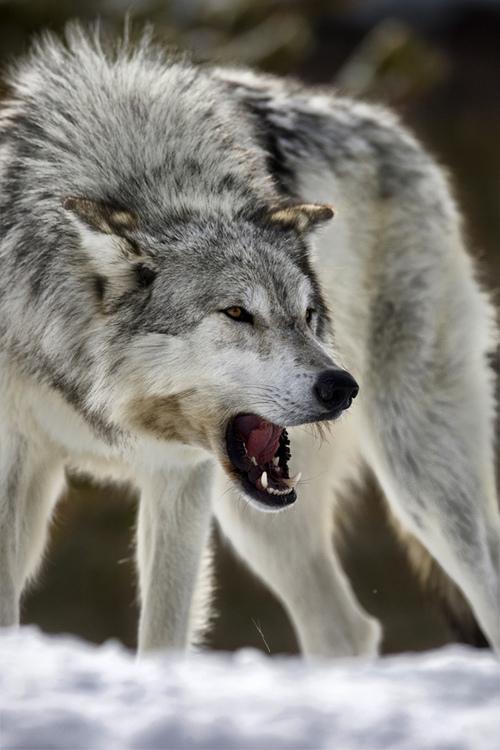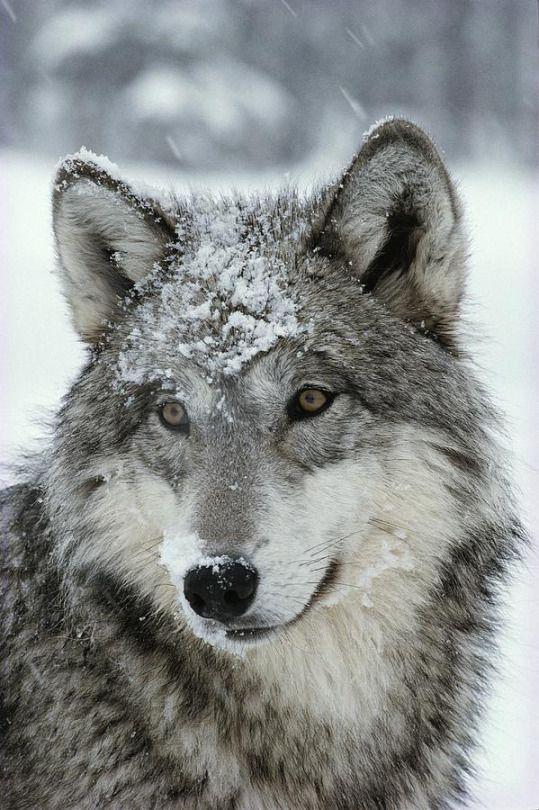The first image is the image on the left, the second image is the image on the right. Evaluate the accuracy of this statement regarding the images: "The wolf in the image on the right has its mouth closed.". Is it true? Answer yes or no. Yes. The first image is the image on the left, the second image is the image on the right. Assess this claim about the two images: "One image features one wolf with snow on its nose, and the other image contains a single wolf, which has its mouth open showing its teeth and stands with its body forward and its head turned rightward.". Correct or not? Answer yes or no. Yes. 